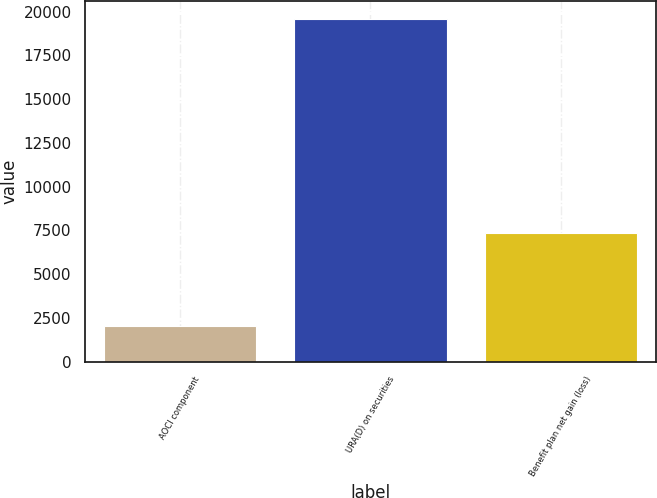Convert chart to OTSL. <chart><loc_0><loc_0><loc_500><loc_500><bar_chart><fcel>AOCI component<fcel>URA(D) on securities<fcel>Benefit plan net gain (loss)<nl><fcel>2012<fcel>19606<fcel>7377<nl></chart> 